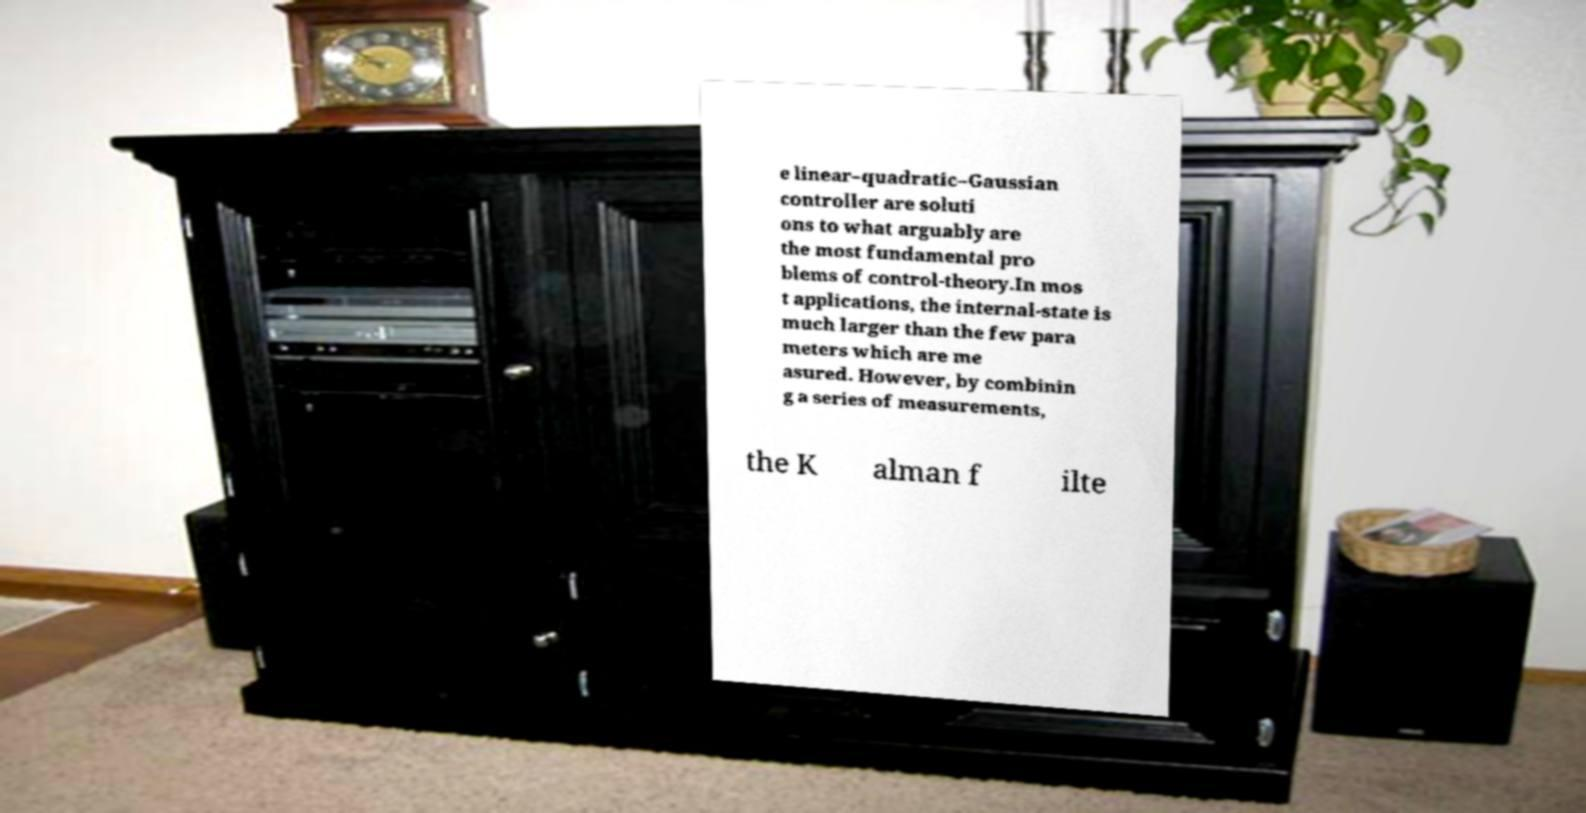Could you assist in decoding the text presented in this image and type it out clearly? e linear–quadratic–Gaussian controller are soluti ons to what arguably are the most fundamental pro blems of control-theory.In mos t applications, the internal-state is much larger than the few para meters which are me asured. However, by combinin g a series of measurements, the K alman f ilte 